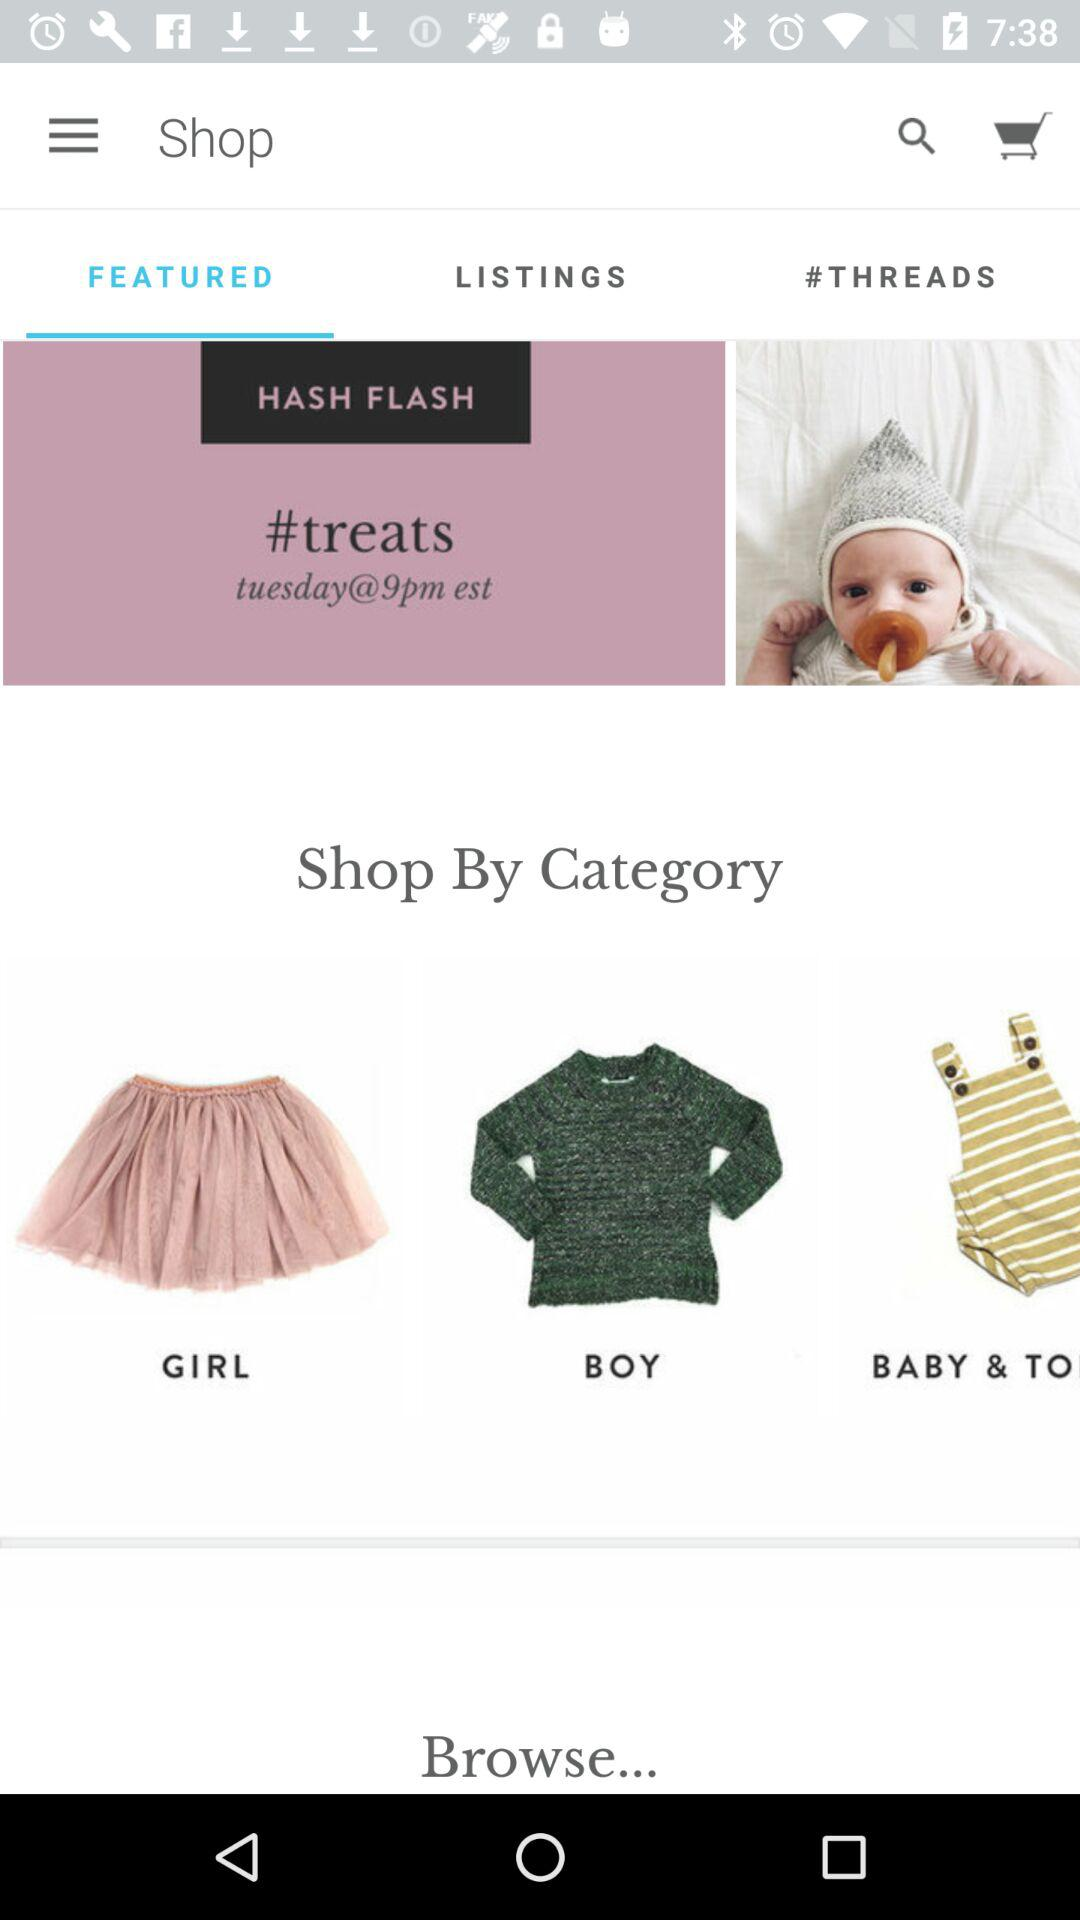What is the shopping category? The shopping categories are "GIRL", "BOY" and "BABY & TO". 